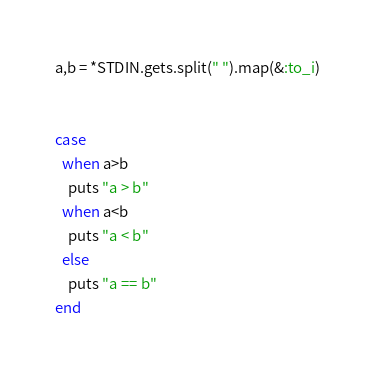Convert code to text. <code><loc_0><loc_0><loc_500><loc_500><_Ruby_>

a,b = *STDIN.gets.split(" ").map(&:to_i)


case
  when a>b
    puts "a > b"
  when a<b
    puts "a < b"
  else
    puts "a == b"
end
</code> 